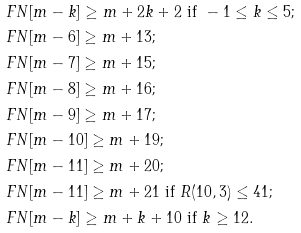Convert formula to latex. <formula><loc_0><loc_0><loc_500><loc_500>& \ F N [ m - k ] \geq m + 2 k + 2 \text { if } - 1 \leq k \leq 5 ; \\ & \ F N [ m - 6 ] \geq m + 1 3 ; \\ & \ F N [ m - 7 ] \geq m + 1 5 ; \\ & \ F N [ m - 8 ] \geq m + 1 6 ; \\ & \ F N [ m - 9 ] \geq m + 1 7 ; \\ & \ F N [ m - 1 0 ] \geq m + 1 9 ; \\ & \ F N [ m - 1 1 ] \geq m + 2 0 ; \\ & \ F N [ m - 1 1 ] \geq m + 2 1 \text { if } R ( 1 0 , 3 ) \leq 4 1 ; \\ & \ F N [ m - k ] \geq m + k + 1 0 \text { if } k \geq 1 2 .</formula> 